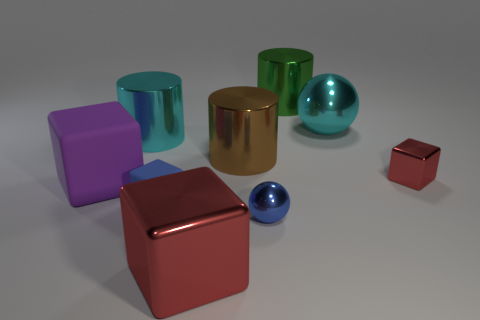Subtract all red blocks. How many were subtracted if there are1red blocks left? 1 Subtract all purple blocks. How many blocks are left? 3 Add 1 small red things. How many objects exist? 10 Subtract all purple blocks. How many blocks are left? 3 Subtract 1 cylinders. How many cylinders are left? 2 Add 7 purple rubber spheres. How many purple rubber spheres exist? 7 Subtract 2 red cubes. How many objects are left? 7 Subtract all cylinders. How many objects are left? 6 Subtract all blue balls. Subtract all blue blocks. How many balls are left? 1 Subtract all purple cylinders. How many red cubes are left? 2 